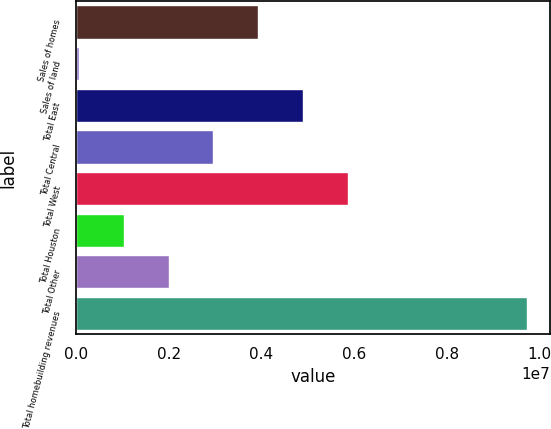<chart> <loc_0><loc_0><loc_500><loc_500><bar_chart><fcel>Sales of homes<fcel>Sales of land<fcel>Total East<fcel>Total Central<fcel>Total West<fcel>Total Houston<fcel>Total Other<fcel>Total homebuilding revenues<nl><fcel>3.93017e+06<fcel>63452<fcel>4.89685e+06<fcel>2.96349e+06<fcel>5.86353e+06<fcel>1.03013e+06<fcel>1.99681e+06<fcel>9.73025e+06<nl></chart> 